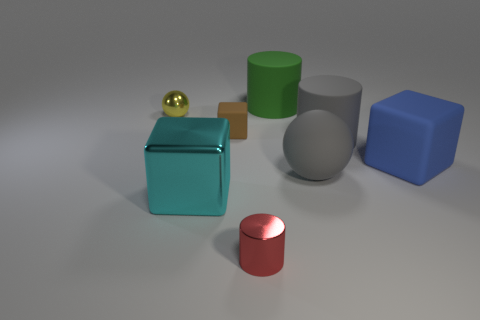What number of things are large cyan balls or small things that are behind the cyan metallic thing?
Your answer should be compact. 2. There is a rubber cube to the left of the cylinder to the left of the big green object; how many blocks are in front of it?
Ensure brevity in your answer.  2. What is the material of the cyan cube that is the same size as the green matte object?
Your response must be concise. Metal. Is there a cyan cube of the same size as the yellow metallic thing?
Provide a short and direct response. No. The big ball is what color?
Your response must be concise. Gray. What color is the big matte cylinder to the right of the object that is behind the small yellow object?
Make the answer very short. Gray. The matte object to the left of the metallic object that is in front of the large cyan metallic cube that is on the left side of the tiny red object is what shape?
Keep it short and to the point. Cube. How many big gray things have the same material as the large green object?
Offer a terse response. 2. There is a sphere that is behind the small brown matte block; what number of things are behind it?
Provide a succinct answer. 1. How many small red cylinders are there?
Your answer should be compact. 1. 